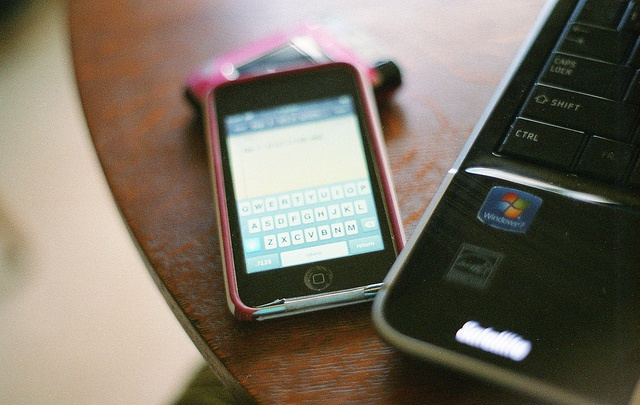Describe the objects in this image and their specific colors. I can see dining table in black, lightgray, maroon, and darkgray tones, laptop in black, gray, darkgreen, and lightgray tones, cell phone in black, gray, lightgray, and darkgreen tones, cell phone in black, ivory, and lightblue tones, and keyboard in black, gray, blue, and darkgreen tones in this image. 